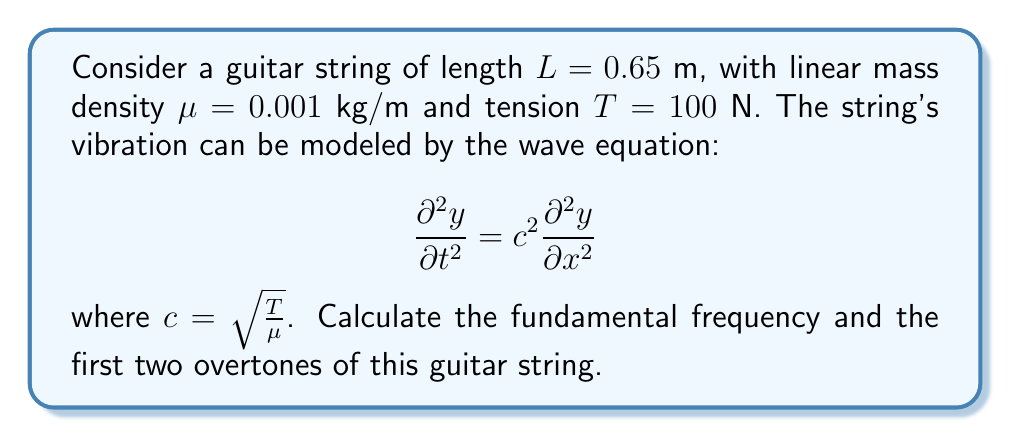Teach me how to tackle this problem. 1. First, we need to calculate the wave speed $c$:
   $$c = \sqrt{\frac{T}{\mu}} = \sqrt{\frac{100}{0.001}} = 316.23 \text{ m/s}$$

2. The general solution for the wave equation with fixed ends (guitar string) is:
   $$y(x,t) = \sum_{n=1}^{\infty} A_n \sin(\frac{n\pi x}{L}) \cos(\frac{n\pi c}{L}t)$$

3. The resonant frequencies are given by:
   $$f_n = \frac{nc}{2L}$$
   where $n = 1, 2, 3, ...$ corresponds to the fundamental frequency and overtones.

4. Calculate the fundamental frequency ($n = 1$):
   $$f_1 = \frac{1 \cdot 316.23}{2 \cdot 0.65} = 243.25 \text{ Hz}$$

5. Calculate the first overtone ($n = 2$):
   $$f_2 = \frac{2 \cdot 316.23}{2 \cdot 0.65} = 486.51 \text{ Hz}$$

6. Calculate the second overtone ($n = 3$):
   $$f_3 = \frac{3 \cdot 316.23}{2 \cdot 0.65} = 729.76 \text{ Hz}$$
Answer: Fundamental frequency: 243.25 Hz
First overtone: 486.51 Hz
Second overtone: 729.76 Hz 